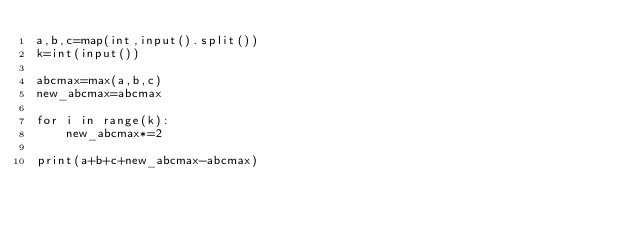Convert code to text. <code><loc_0><loc_0><loc_500><loc_500><_Python_>a,b,c=map(int,input().split())
k=int(input())

abcmax=max(a,b,c)
new_abcmax=abcmax

for i in range(k):
    new_abcmax*=2

print(a+b+c+new_abcmax-abcmax)</code> 